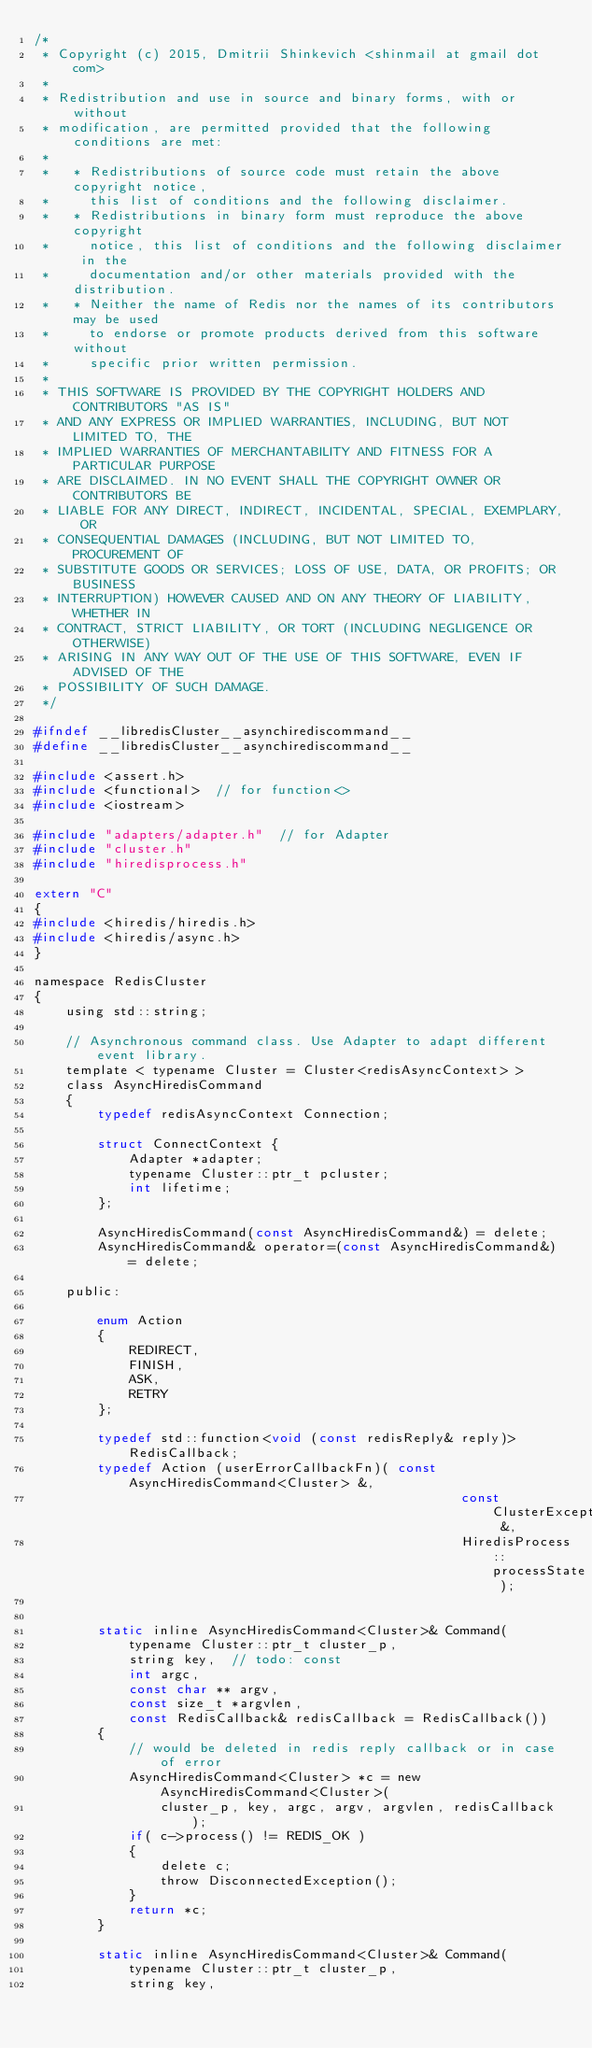<code> <loc_0><loc_0><loc_500><loc_500><_C_>/*
 * Copyright (c) 2015, Dmitrii Shinkevich <shinmail at gmail dot com>
 *
 * Redistribution and use in source and binary forms, with or without
 * modification, are permitted provided that the following conditions are met:
 *
 *   * Redistributions of source code must retain the above copyright notice,
 *     this list of conditions and the following disclaimer.
 *   * Redistributions in binary form must reproduce the above copyright
 *     notice, this list of conditions and the following disclaimer in the
 *     documentation and/or other materials provided with the distribution.
 *   * Neither the name of Redis nor the names of its contributors may be used
 *     to endorse or promote products derived from this software without
 *     specific prior written permission.
 *
 * THIS SOFTWARE IS PROVIDED BY THE COPYRIGHT HOLDERS AND CONTRIBUTORS "AS IS"
 * AND ANY EXPRESS OR IMPLIED WARRANTIES, INCLUDING, BUT NOT LIMITED TO, THE
 * IMPLIED WARRANTIES OF MERCHANTABILITY AND FITNESS FOR A PARTICULAR PURPOSE
 * ARE DISCLAIMED. IN NO EVENT SHALL THE COPYRIGHT OWNER OR CONTRIBUTORS BE
 * LIABLE FOR ANY DIRECT, INDIRECT, INCIDENTAL, SPECIAL, EXEMPLARY, OR
 * CONSEQUENTIAL DAMAGES (INCLUDING, BUT NOT LIMITED TO, PROCUREMENT OF
 * SUBSTITUTE GOODS OR SERVICES; LOSS OF USE, DATA, OR PROFITS; OR BUSINESS
 * INTERRUPTION) HOWEVER CAUSED AND ON ANY THEORY OF LIABILITY, WHETHER IN
 * CONTRACT, STRICT LIABILITY, OR TORT (INCLUDING NEGLIGENCE OR OTHERWISE)
 * ARISING IN ANY WAY OUT OF THE USE OF THIS SOFTWARE, EVEN IF ADVISED OF THE
 * POSSIBILITY OF SUCH DAMAGE.
 */

#ifndef __libredisCluster__asynchirediscommand__
#define __libredisCluster__asynchirediscommand__

#include <assert.h>
#include <functional>  // for function<>
#include <iostream>

#include "adapters/adapter.h"  // for Adapter
#include "cluster.h"
#include "hiredisprocess.h"

extern "C"
{
#include <hiredis/hiredis.h>
#include <hiredis/async.h>
}

namespace RedisCluster
{
    using std::string;
    
    // Asynchronous command class. Use Adapter to adapt different event library.
    template < typename Cluster = Cluster<redisAsyncContext> >
    class AsyncHiredisCommand
    {
        typedef redisAsyncContext Connection;

        struct ConnectContext {
            Adapter *adapter;
            typename Cluster::ptr_t pcluster;
            int lifetime;
        };
        
        AsyncHiredisCommand(const AsyncHiredisCommand&) = delete;
        AsyncHiredisCommand& operator=(const AsyncHiredisCommand&) = delete;
        
    public:
        
        enum Action
        {
            REDIRECT,
            FINISH,
            ASK,
            RETRY
        };
        
        typedef std::function<void (const redisReply& reply)> RedisCallback;
        typedef Action (userErrorCallbackFn)( const AsyncHiredisCommand<Cluster> &,
                                                      const ClusterException &,
                                                      HiredisProcess::processState );
        
        
        static inline AsyncHiredisCommand<Cluster>& Command(
            typename Cluster::ptr_t cluster_p,
            string key,  // todo: const
            int argc,
            const char ** argv,
            const size_t *argvlen,
            const RedisCallback& redisCallback = RedisCallback())
        {
            // would be deleted in redis reply callback or in case of error
            AsyncHiredisCommand<Cluster> *c = new AsyncHiredisCommand<Cluster>(
                cluster_p, key, argc, argv, argvlen, redisCallback );
            if( c->process() != REDIS_OK )
            {
                delete c;
                throw DisconnectedException();
            }
            return *c;
        }
        
        static inline AsyncHiredisCommand<Cluster>& Command(
            typename Cluster::ptr_t cluster_p,
            string key,</code> 